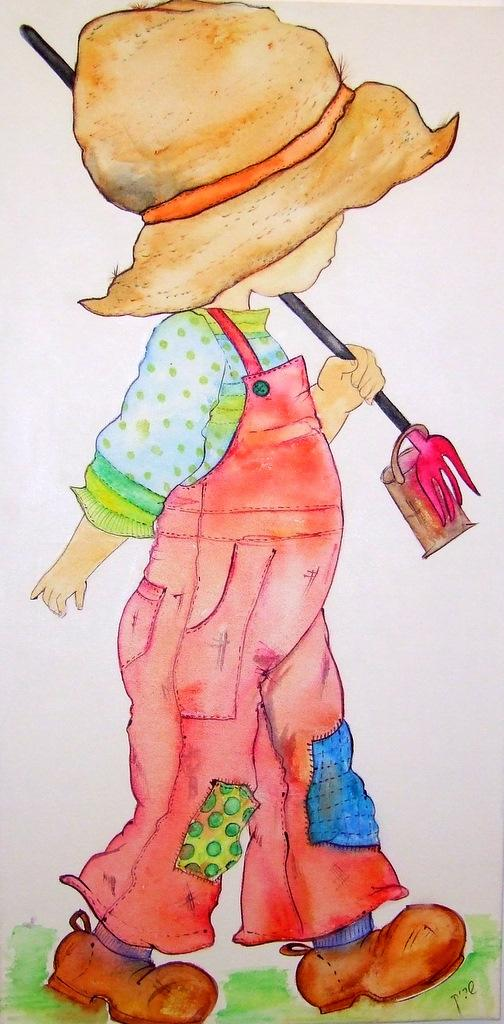What is the main subject of the image? There is a painting in the image. What type of journey does the painting depict in the image? There is no journey depicted in the image, as it only features a painting. Can you provide a list of all the partners mentioned in the painting? There are no partners mentioned in the painting, as it is not a narrative or scene with characters. 